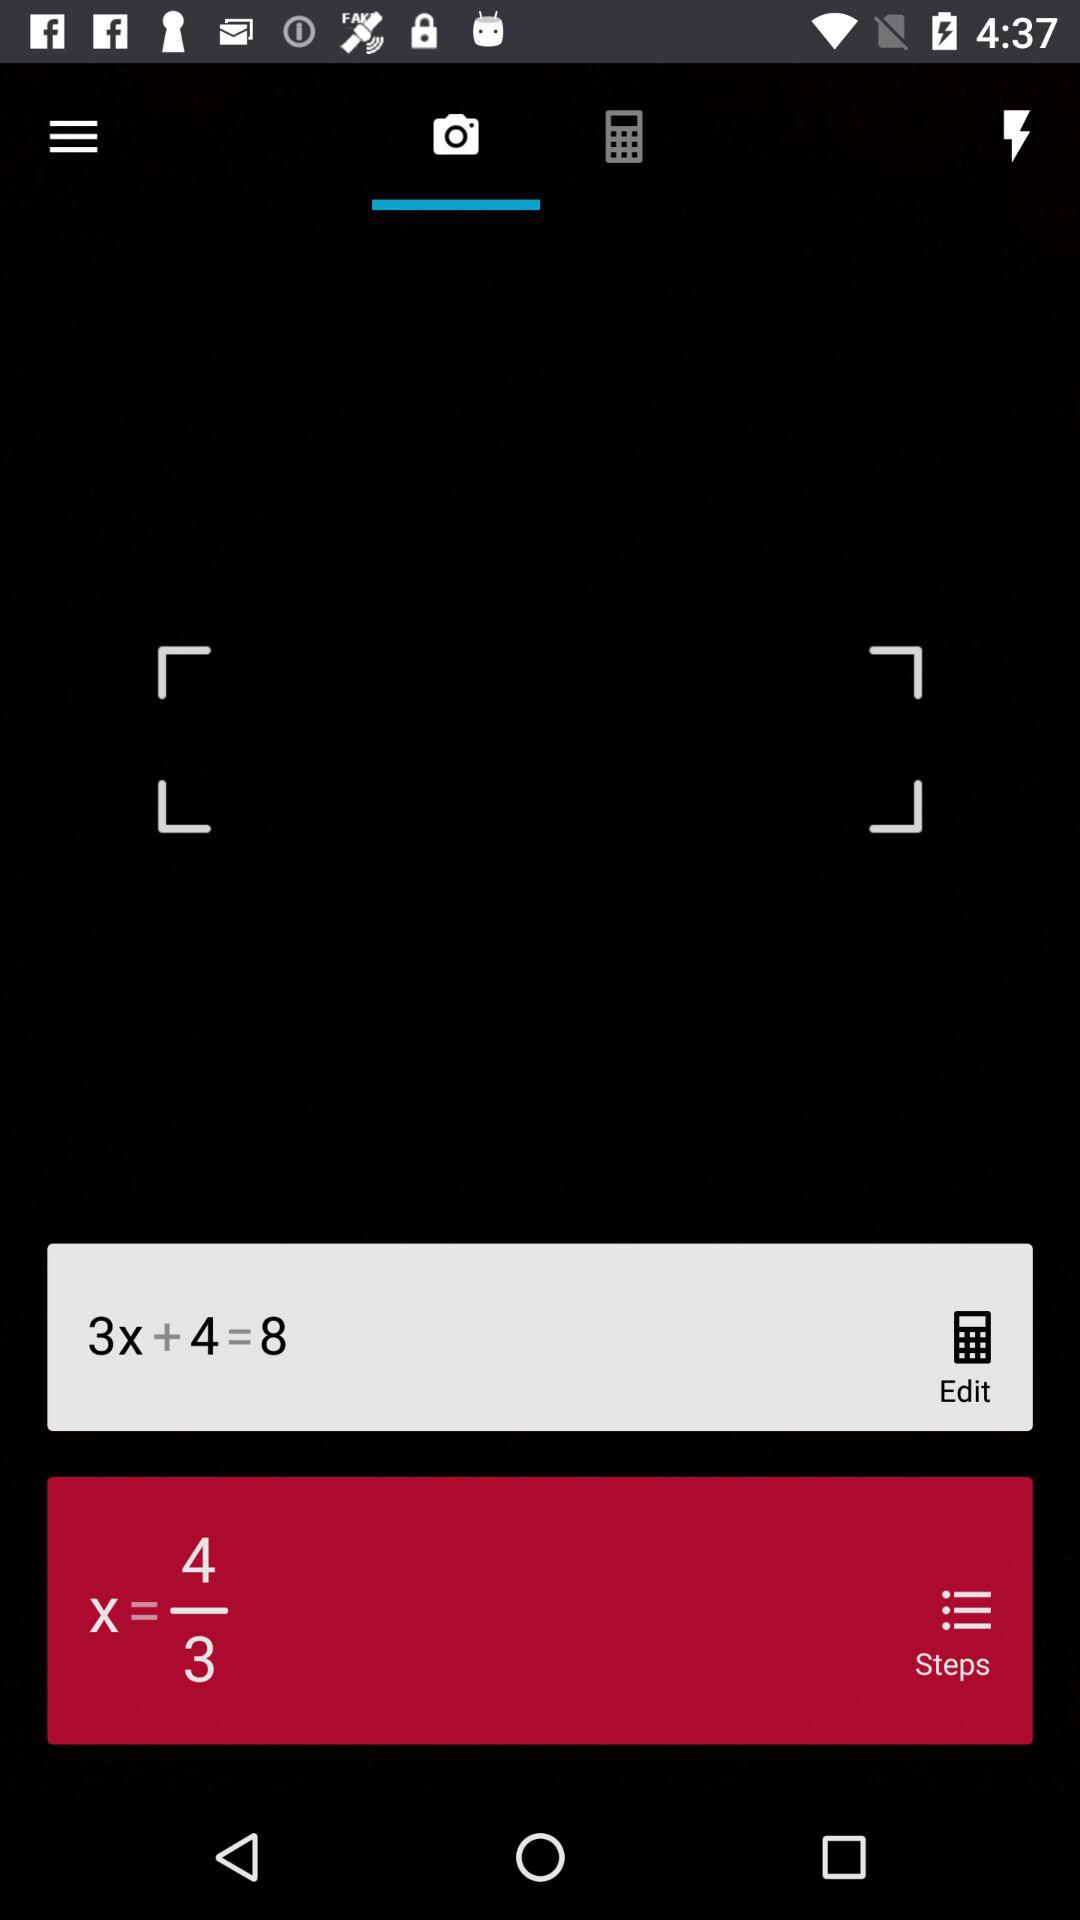What is the value of X? The value of X is 4/3. 